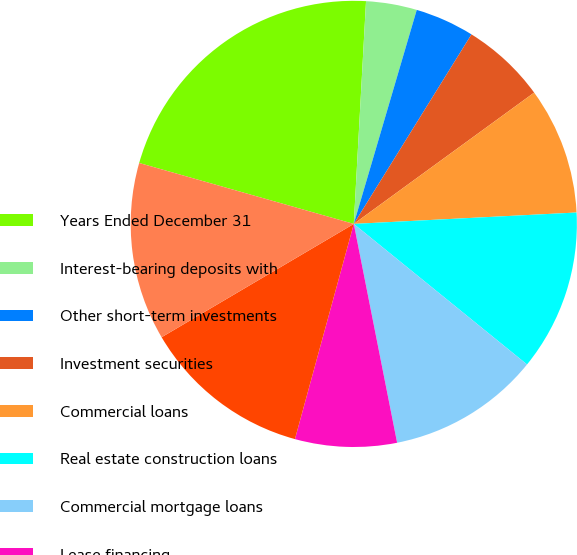Convert chart to OTSL. <chart><loc_0><loc_0><loc_500><loc_500><pie_chart><fcel>Years Ended December 31<fcel>Interest-bearing deposits with<fcel>Other short-term investments<fcel>Investment securities<fcel>Commercial loans<fcel>Real estate construction loans<fcel>Commercial mortgage loans<fcel>Lease financing<fcel>International loans<fcel>Residential mortgage loans<nl><fcel>21.47%<fcel>3.68%<fcel>4.29%<fcel>6.14%<fcel>9.2%<fcel>11.66%<fcel>11.04%<fcel>7.36%<fcel>12.27%<fcel>12.88%<nl></chart> 